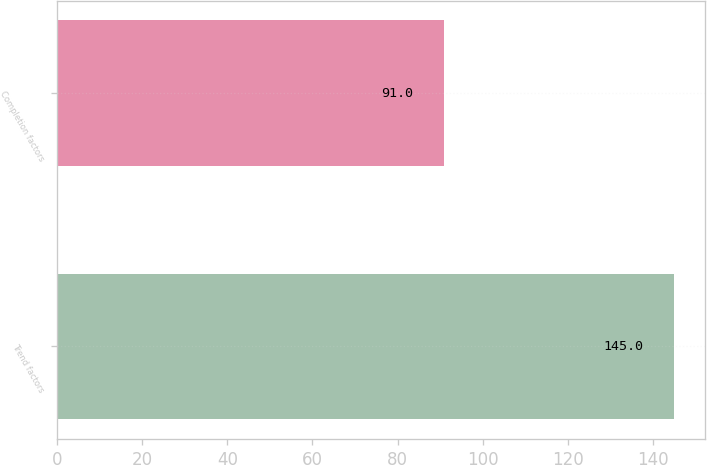Convert chart to OTSL. <chart><loc_0><loc_0><loc_500><loc_500><bar_chart><fcel>Trend factors<fcel>Completion factors<nl><fcel>145<fcel>91<nl></chart> 